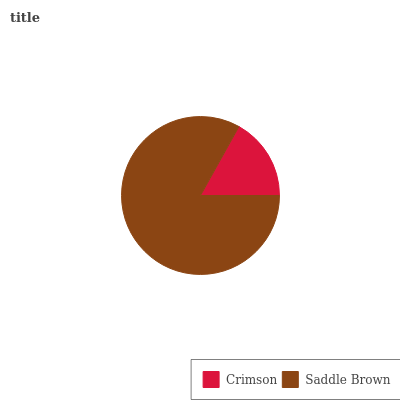Is Crimson the minimum?
Answer yes or no. Yes. Is Saddle Brown the maximum?
Answer yes or no. Yes. Is Saddle Brown the minimum?
Answer yes or no. No. Is Saddle Brown greater than Crimson?
Answer yes or no. Yes. Is Crimson less than Saddle Brown?
Answer yes or no. Yes. Is Crimson greater than Saddle Brown?
Answer yes or no. No. Is Saddle Brown less than Crimson?
Answer yes or no. No. Is Saddle Brown the high median?
Answer yes or no. Yes. Is Crimson the low median?
Answer yes or no. Yes. Is Crimson the high median?
Answer yes or no. No. Is Saddle Brown the low median?
Answer yes or no. No. 